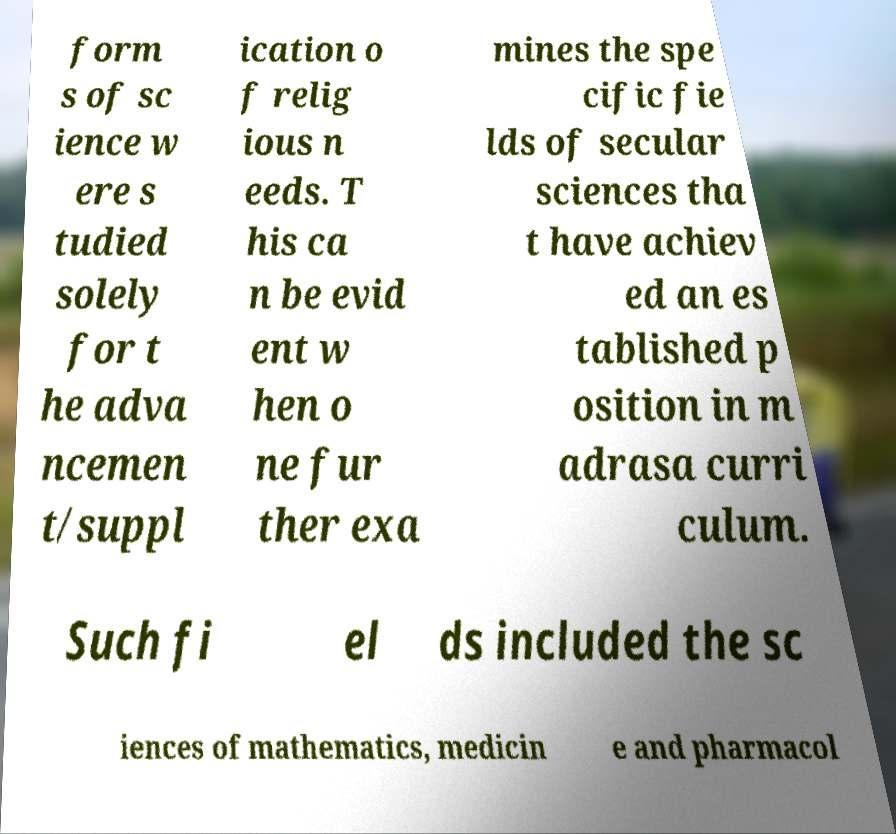Can you accurately transcribe the text from the provided image for me? form s of sc ience w ere s tudied solely for t he adva ncemen t/suppl ication o f relig ious n eeds. T his ca n be evid ent w hen o ne fur ther exa mines the spe cific fie lds of secular sciences tha t have achiev ed an es tablished p osition in m adrasa curri culum. Such fi el ds included the sc iences of mathematics, medicin e and pharmacol 